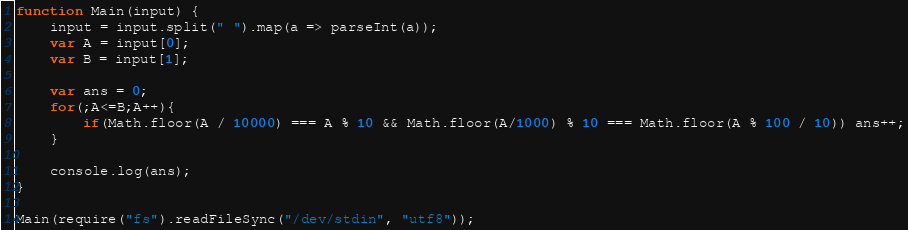Convert code to text. <code><loc_0><loc_0><loc_500><loc_500><_JavaScript_>function Main(input) {
	input = input.split(" ").map(a => parseInt(a));
	var A = input[0];
	var B = input[1];
	
	var ans = 0;
	for(;A<=B;A++){
		if(Math.floor(A / 10000) === A % 10 && Math.floor(A/1000) % 10 === Math.floor(A % 100 / 10)) ans++;
	}
	
	console.log(ans);
}

Main(require("fs").readFileSync("/dev/stdin", "utf8"));</code> 